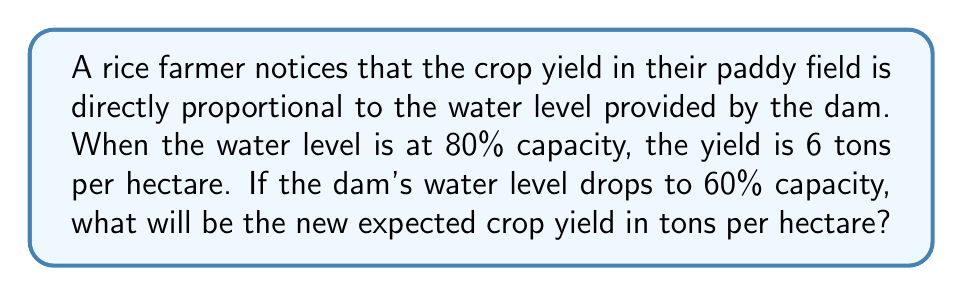Solve this math problem. Let's approach this step-by-step:

1) Let $y$ be the yield in tons per hectare and $x$ be the water level as a percentage of capacity.

2) We're told that $y$ is directly proportional to $x$. This means we can write:

   $y = kx$

   where $k$ is the constant of proportionality.

3) We know that when $x = 80\%$, $y = 6$ tons/hectare. Let's use this to find $k$:

   $6 = k(80)$
   $k = \frac{6}{80} = 0.075$

4) So our equation is:

   $y = 0.075x$

5) Now, we want to find $y$ when $x = 60\%$:

   $y = 0.075(60) = 4.5$

Therefore, when the water level drops to 60% capacity, the expected crop yield will be 4.5 tons per hectare.
Answer: 4.5 tons/hectare 